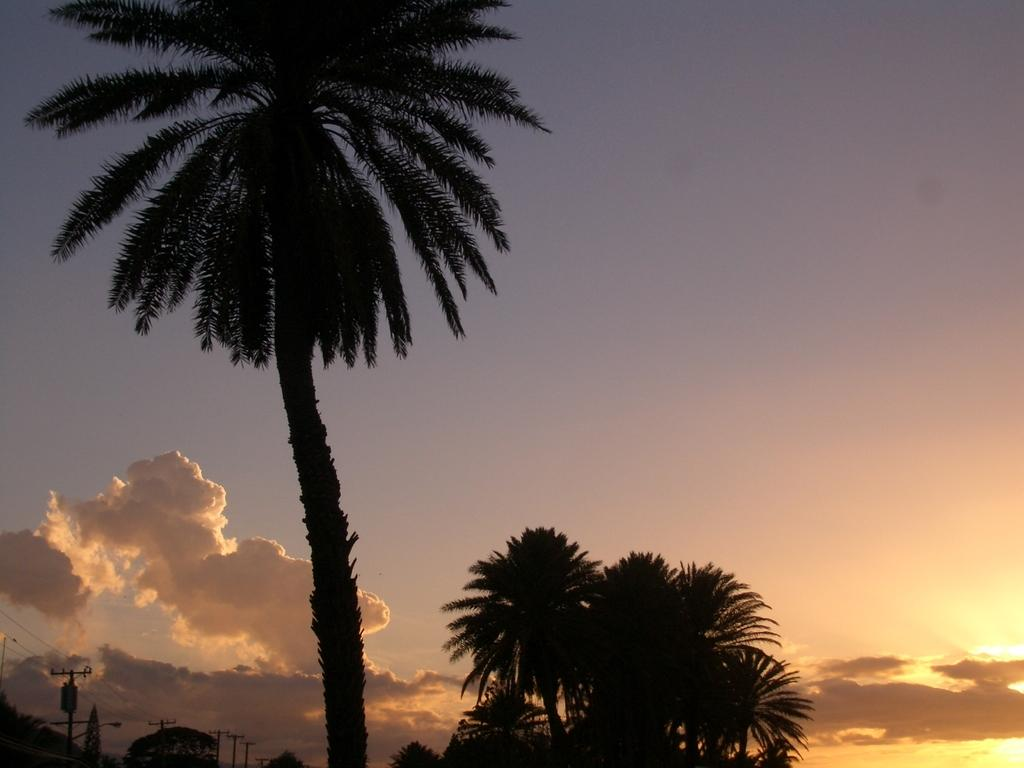What type of vegetation can be seen in the image? There are trees in the image. What else can be seen in the image besides trees? There are poles with wires in the image. What is visible in the background of the image? Sunlight is visible in the background, and there are clouds in the sky. Can you see a snake slithering down the slope in the image? There is no snake or slope present in the image. What type of wind, zephyr, can be felt in the image? The image is a still photograph and does not depict any wind or weather conditions, so it is not possible to determine if a zephyr can be felt. 